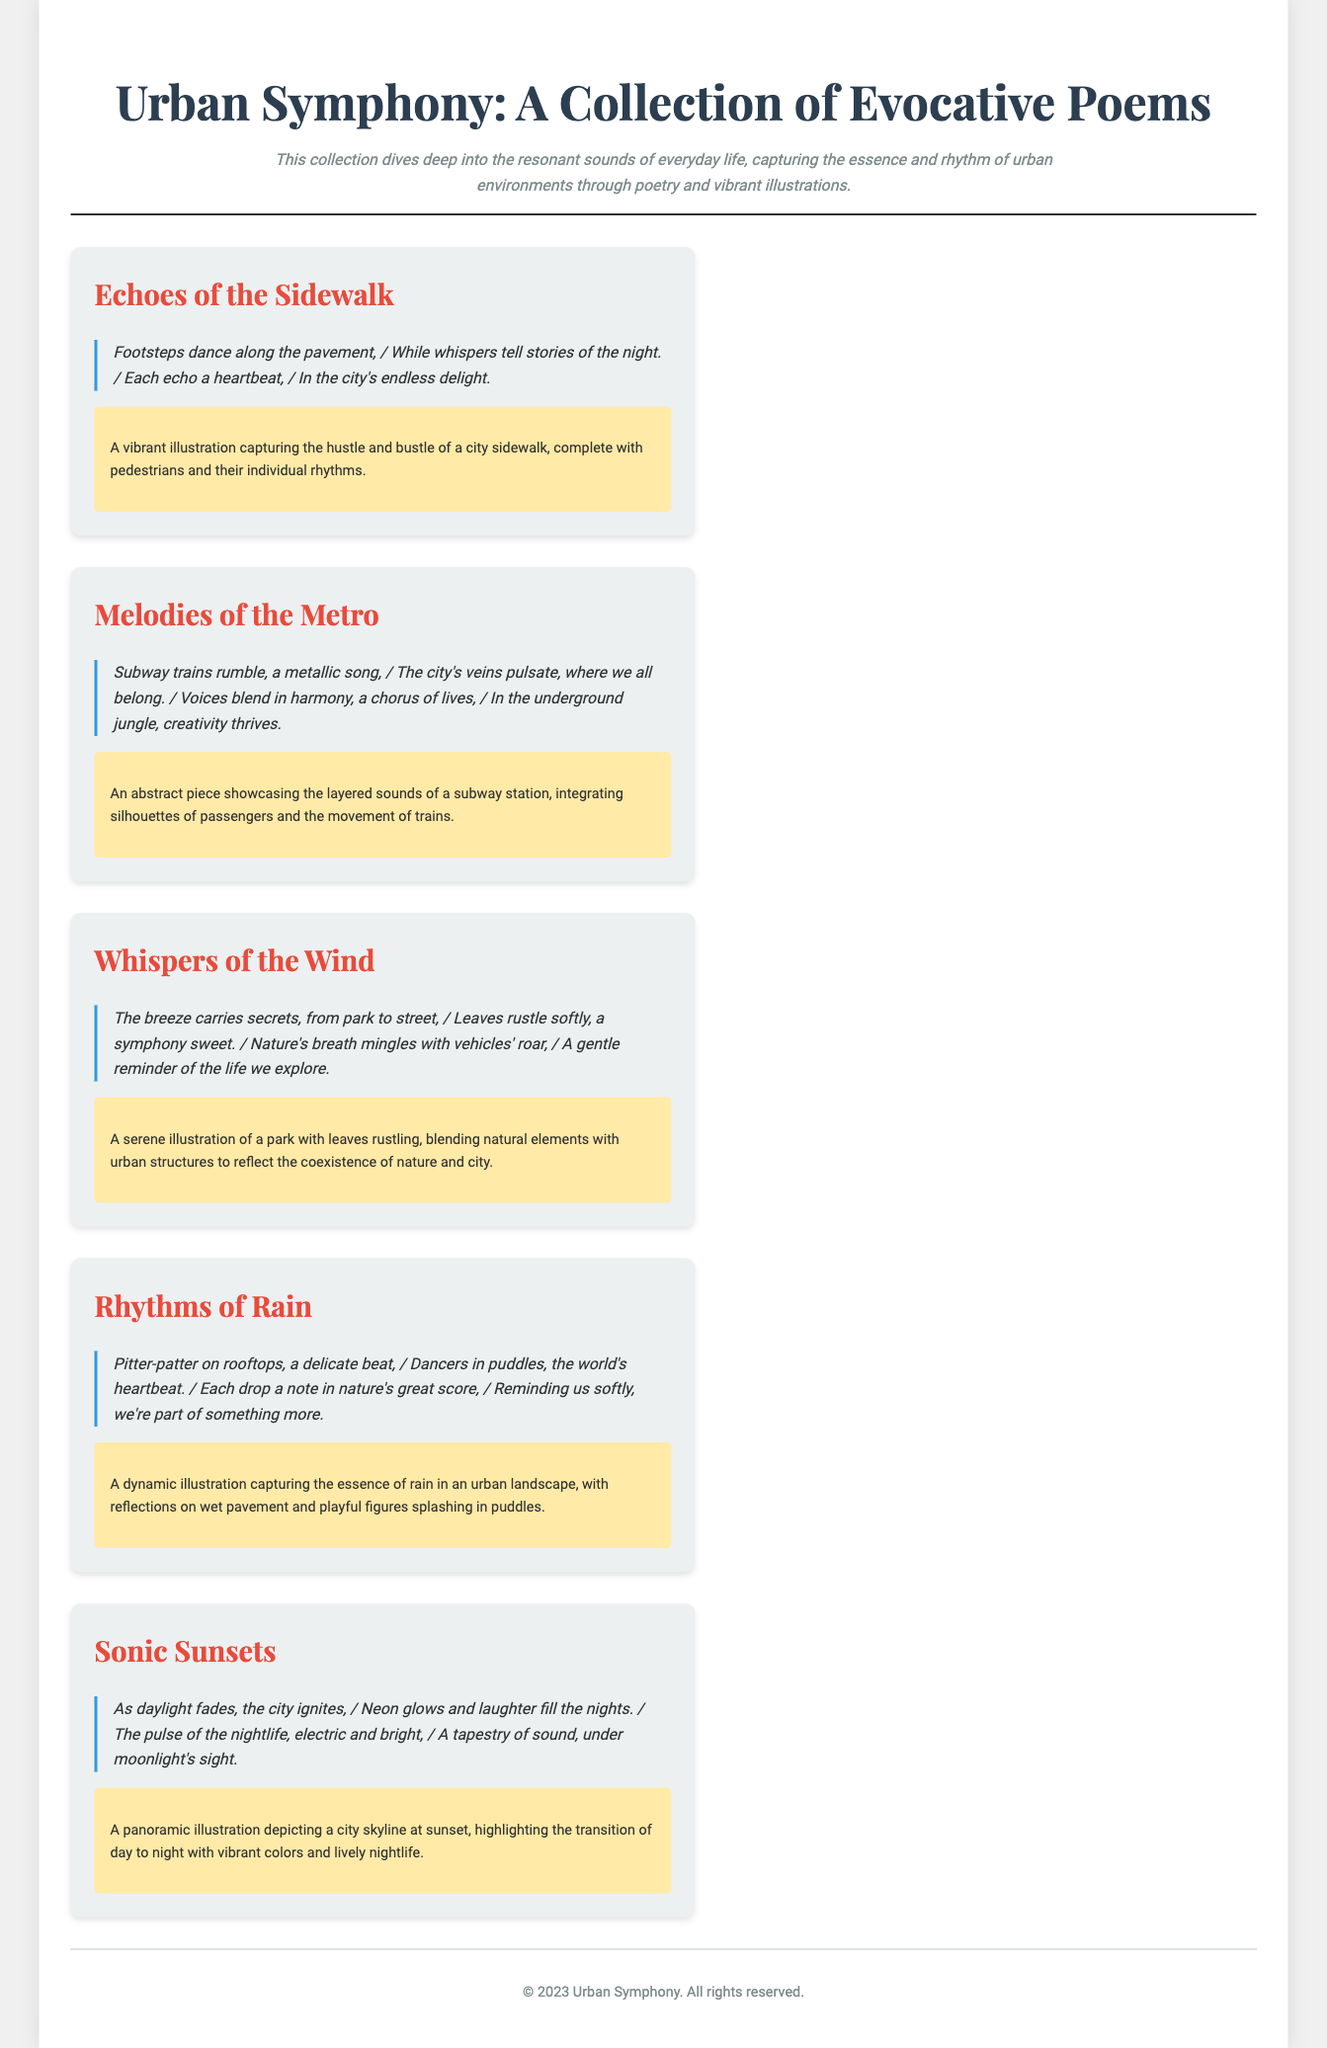What is the title of the collection? The title of the collection is found in the header section of the document.
Answer: Urban Symphony: A Collection of Evocative Poems How many themes are presented in the collection? The number of themes is determined by counting the separate sections under the main content.
Answer: Five What is the first poem excerpt about? The first poem excerpt discusses the sound of footsteps on the pavement and the stories they tell.
Answer: Footsteps dance along the pavement Which theme corresponds with the concept of rain? The theme's title is specified within the main content and relates to rain sounds.
Answer: Rhythms of Rain What type of illustration accompanies "Melodies of the Metro"? This is found in the description of the illustration associated with this specific theme.
Answer: An abstract piece Who is the author of the collection? This information is typically found at the bottom of the document but not explicitly mentioned.
Answer: Not specified What visual concept is highlighted in "Whispers of the Wind"? This relates to the description provided for the illustration for that theme.
Answer: A serene illustration Which urban feature does "Sonic Sunsets" emphasize? The focus of this theme is derived from the content regarding the transition of day to night.
Answer: City skyline at sunset 